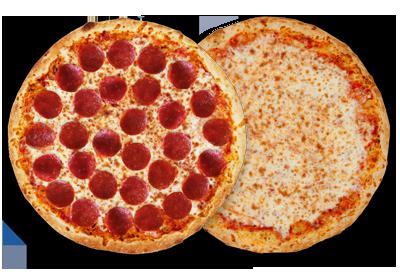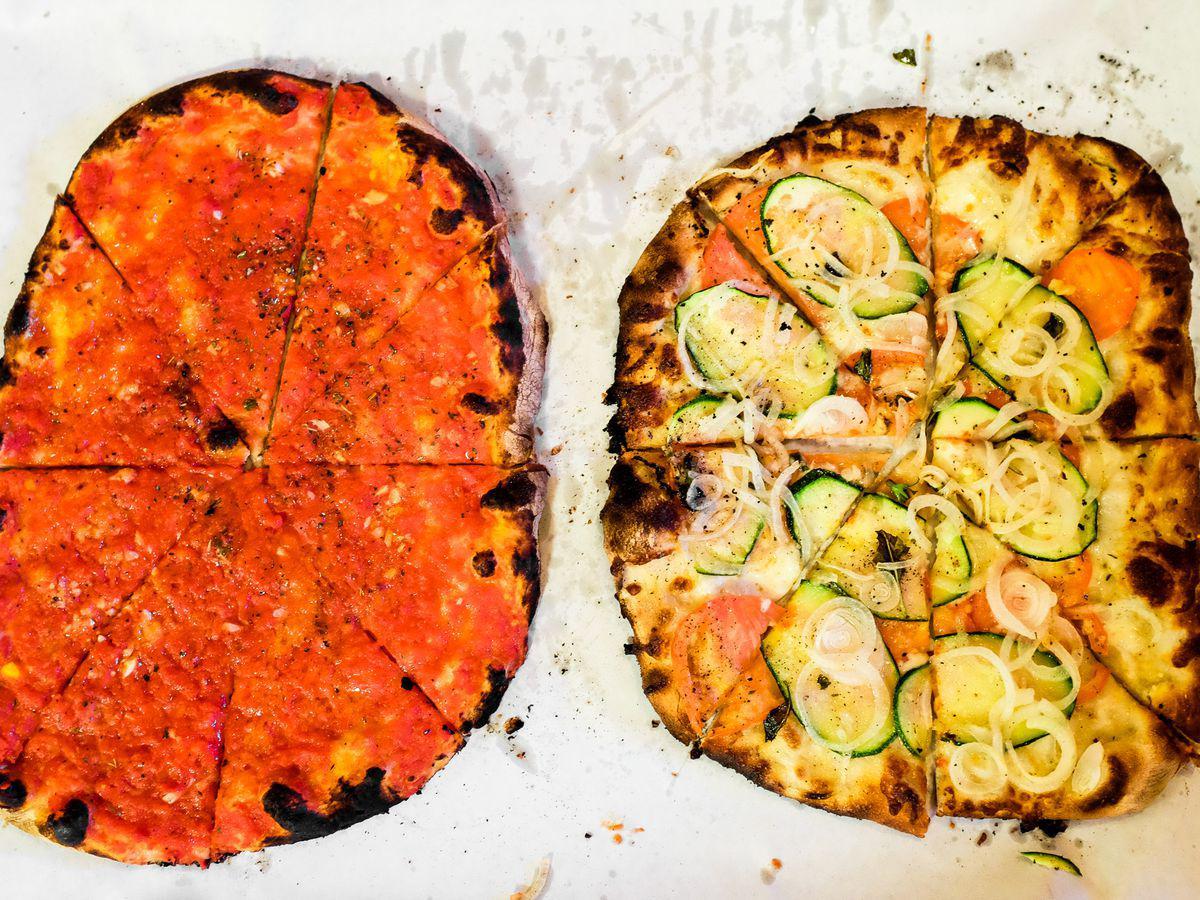The first image is the image on the left, the second image is the image on the right. Given the left and right images, does the statement "At least 2 pizzas have pepperoni on them in one of the pictures." hold true? Answer yes or no. No. 